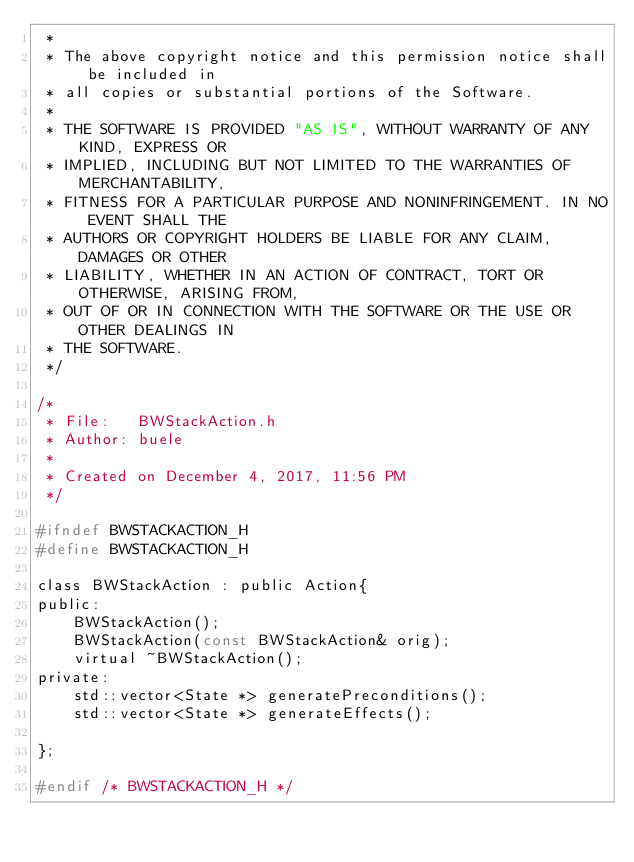<code> <loc_0><loc_0><loc_500><loc_500><_C_> *
 * The above copyright notice and this permission notice shall be included in
 * all copies or substantial portions of the Software.
 *
 * THE SOFTWARE IS PROVIDED "AS IS", WITHOUT WARRANTY OF ANY KIND, EXPRESS OR
 * IMPLIED, INCLUDING BUT NOT LIMITED TO THE WARRANTIES OF MERCHANTABILITY,
 * FITNESS FOR A PARTICULAR PURPOSE AND NONINFRINGEMENT. IN NO EVENT SHALL THE
 * AUTHORS OR COPYRIGHT HOLDERS BE LIABLE FOR ANY CLAIM, DAMAGES OR OTHER
 * LIABILITY, WHETHER IN AN ACTION OF CONTRACT, TORT OR OTHERWISE, ARISING FROM,
 * OUT OF OR IN CONNECTION WITH THE SOFTWARE OR THE USE OR OTHER DEALINGS IN
 * THE SOFTWARE.
 */

/* 
 * File:   BWStackAction.h
 * Author: buele
 *
 * Created on December 4, 2017, 11:56 PM
 */

#ifndef BWSTACKACTION_H
#define BWSTACKACTION_H

class BWStackAction : public Action{
public:
    BWStackAction();
    BWStackAction(const BWStackAction& orig);
    virtual ~BWStackAction();
private:
    std::vector<State *> generatePreconditions();
    std::vector<State *> generateEffects();

};

#endif /* BWSTACKACTION_H */

</code> 